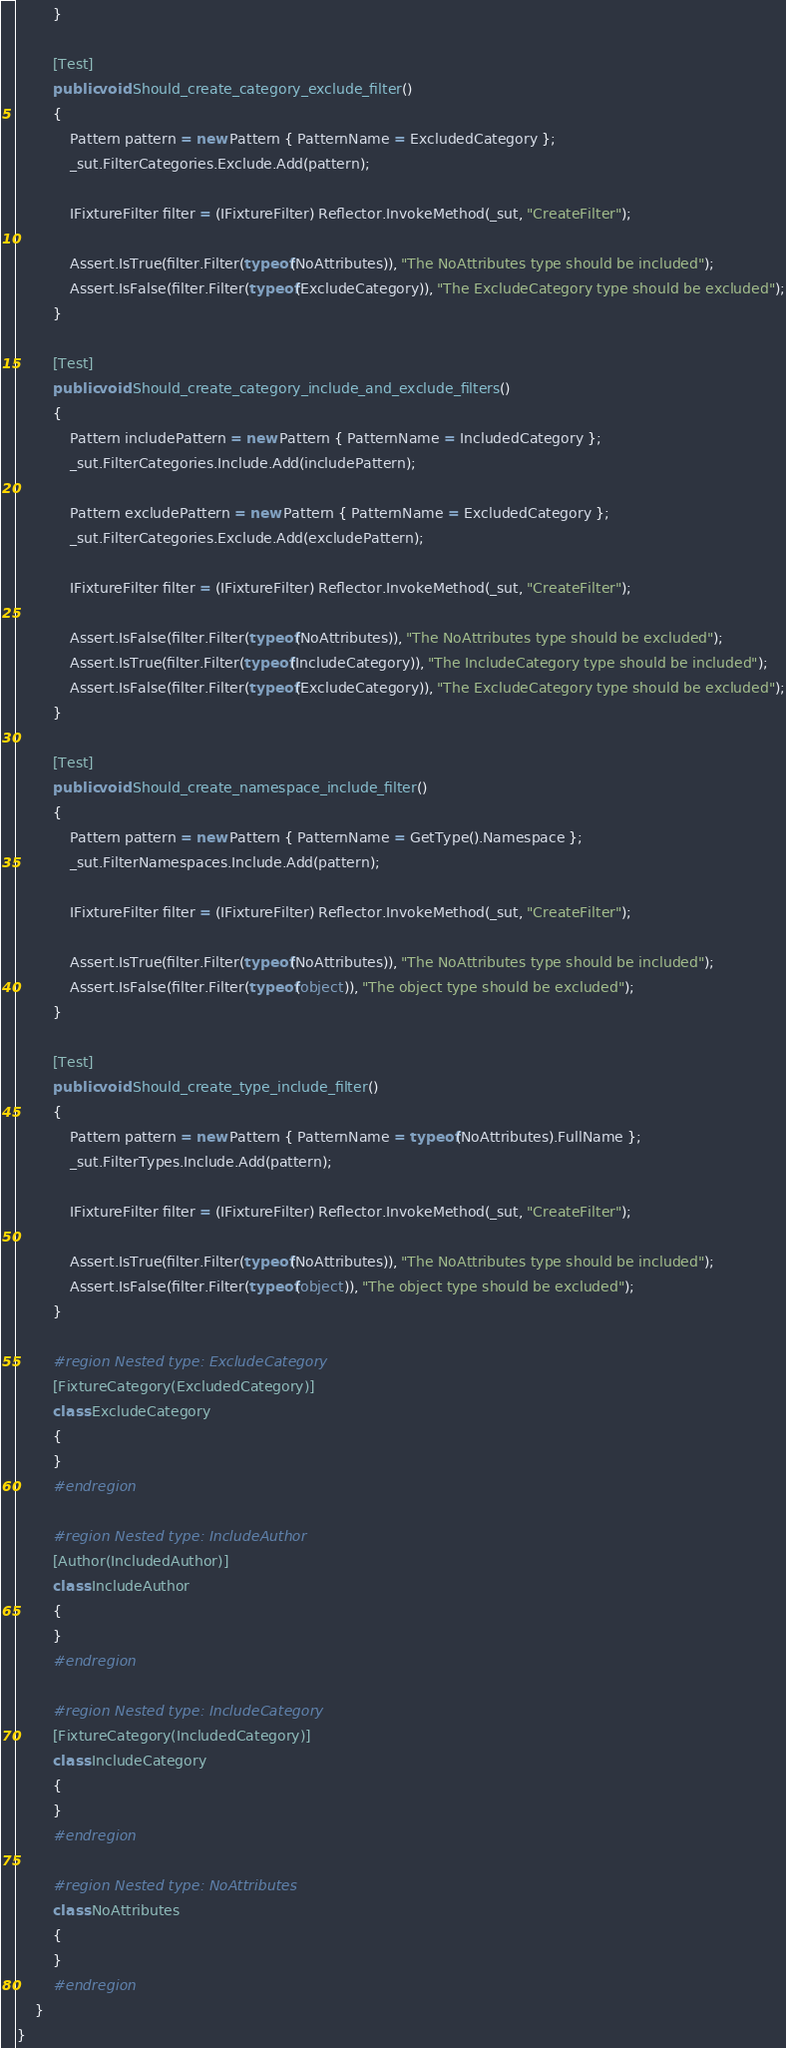Convert code to text. <code><loc_0><loc_0><loc_500><loc_500><_C#_>		}

		[Test]
		public void Should_create_category_exclude_filter()
		{
			Pattern pattern = new Pattern { PatternName = ExcludedCategory };
			_sut.FilterCategories.Exclude.Add(pattern);

			IFixtureFilter filter = (IFixtureFilter) Reflector.InvokeMethod(_sut, "CreateFilter");

			Assert.IsTrue(filter.Filter(typeof(NoAttributes)), "The NoAttributes type should be included");
			Assert.IsFalse(filter.Filter(typeof(ExcludeCategory)), "The ExcludeCategory type should be excluded");
		}

		[Test]
		public void Should_create_category_include_and_exclude_filters()
		{
			Pattern includePattern = new Pattern { PatternName = IncludedCategory };
			_sut.FilterCategories.Include.Add(includePattern);

			Pattern excludePattern = new Pattern { PatternName = ExcludedCategory };
			_sut.FilterCategories.Exclude.Add(excludePattern);

			IFixtureFilter filter = (IFixtureFilter) Reflector.InvokeMethod(_sut, "CreateFilter");

			Assert.IsFalse(filter.Filter(typeof(NoAttributes)), "The NoAttributes type should be excluded");
			Assert.IsTrue(filter.Filter(typeof(IncludeCategory)), "The IncludeCategory type should be included");
			Assert.IsFalse(filter.Filter(typeof(ExcludeCategory)), "The ExcludeCategory type should be excluded");
		}

		[Test]
		public void Should_create_namespace_include_filter()
		{
			Pattern pattern = new Pattern { PatternName = GetType().Namespace };
			_sut.FilterNamespaces.Include.Add(pattern);

			IFixtureFilter filter = (IFixtureFilter) Reflector.InvokeMethod(_sut, "CreateFilter");

			Assert.IsTrue(filter.Filter(typeof(NoAttributes)), "The NoAttributes type should be included");
			Assert.IsFalse(filter.Filter(typeof(object)), "The object type should be excluded");
		}

		[Test]
		public void Should_create_type_include_filter()
		{
			Pattern pattern = new Pattern { PatternName = typeof(NoAttributes).FullName };
			_sut.FilterTypes.Include.Add(pattern);

			IFixtureFilter filter = (IFixtureFilter) Reflector.InvokeMethod(_sut, "CreateFilter");

			Assert.IsTrue(filter.Filter(typeof(NoAttributes)), "The NoAttributes type should be included");
			Assert.IsFalse(filter.Filter(typeof(object)), "The object type should be excluded");
		}

		#region Nested type: ExcludeCategory
		[FixtureCategory(ExcludedCategory)]
		class ExcludeCategory
		{
		}
		#endregion

		#region Nested type: IncludeAuthor
		[Author(IncludedAuthor)]
		class IncludeAuthor
		{
		}
		#endregion

		#region Nested type: IncludeCategory
		[FixtureCategory(IncludedCategory)]
		class IncludeCategory
		{
		}
		#endregion

		#region Nested type: NoAttributes
		class NoAttributes
		{
		}
		#endregion
	}
}</code> 